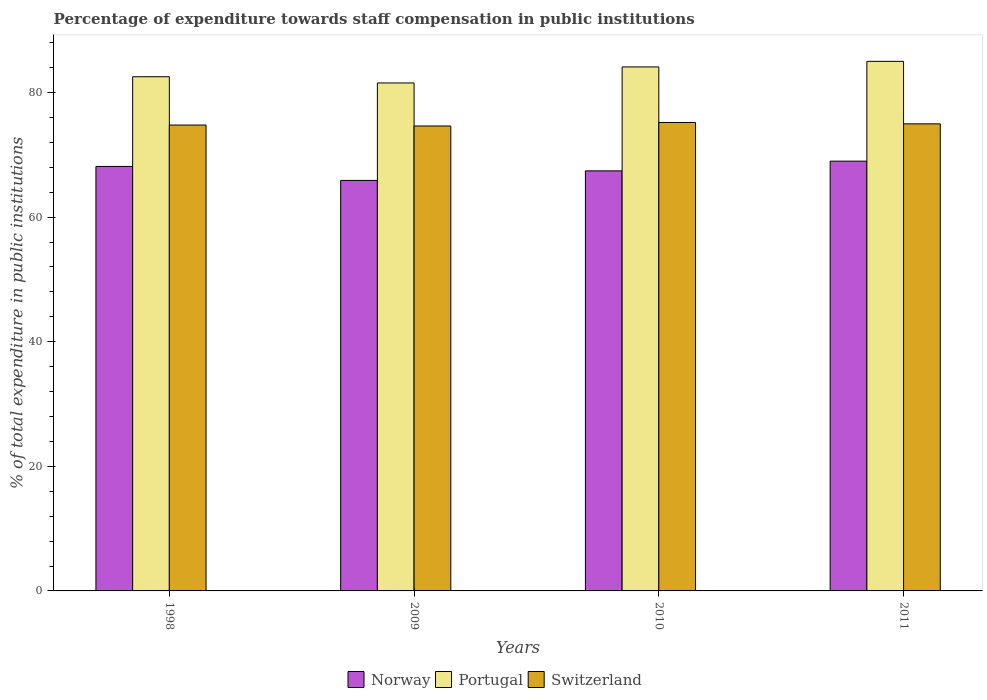How many different coloured bars are there?
Provide a succinct answer. 3. How many groups of bars are there?
Offer a terse response. 4. Are the number of bars per tick equal to the number of legend labels?
Give a very brief answer. Yes. How many bars are there on the 3rd tick from the left?
Keep it short and to the point. 3. How many bars are there on the 2nd tick from the right?
Your answer should be very brief. 3. In how many cases, is the number of bars for a given year not equal to the number of legend labels?
Ensure brevity in your answer.  0. What is the percentage of expenditure towards staff compensation in Portugal in 2009?
Offer a very short reply. 81.54. Across all years, what is the maximum percentage of expenditure towards staff compensation in Norway?
Ensure brevity in your answer.  68.99. Across all years, what is the minimum percentage of expenditure towards staff compensation in Switzerland?
Make the answer very short. 74.63. What is the total percentage of expenditure towards staff compensation in Portugal in the graph?
Keep it short and to the point. 333.19. What is the difference between the percentage of expenditure towards staff compensation in Norway in 2009 and that in 2011?
Keep it short and to the point. -3.09. What is the difference between the percentage of expenditure towards staff compensation in Norway in 2011 and the percentage of expenditure towards staff compensation in Portugal in 1998?
Ensure brevity in your answer.  -13.55. What is the average percentage of expenditure towards staff compensation in Switzerland per year?
Provide a succinct answer. 74.89. In the year 1998, what is the difference between the percentage of expenditure towards staff compensation in Switzerland and percentage of expenditure towards staff compensation in Norway?
Make the answer very short. 6.64. In how many years, is the percentage of expenditure towards staff compensation in Switzerland greater than 60 %?
Offer a very short reply. 4. What is the ratio of the percentage of expenditure towards staff compensation in Switzerland in 2009 to that in 2011?
Provide a short and direct response. 1. What is the difference between the highest and the second highest percentage of expenditure towards staff compensation in Norway?
Provide a short and direct response. 0.85. What is the difference between the highest and the lowest percentage of expenditure towards staff compensation in Portugal?
Ensure brevity in your answer.  3.47. What does the 3rd bar from the right in 2010 represents?
Give a very brief answer. Norway. How many bars are there?
Your answer should be compact. 12. What is the difference between two consecutive major ticks on the Y-axis?
Provide a short and direct response. 20. Are the values on the major ticks of Y-axis written in scientific E-notation?
Give a very brief answer. No. Does the graph contain any zero values?
Your answer should be compact. No. Where does the legend appear in the graph?
Your answer should be compact. Bottom center. How many legend labels are there?
Provide a short and direct response. 3. What is the title of the graph?
Provide a succinct answer. Percentage of expenditure towards staff compensation in public institutions. Does "Dominican Republic" appear as one of the legend labels in the graph?
Provide a short and direct response. No. What is the label or title of the X-axis?
Offer a terse response. Years. What is the label or title of the Y-axis?
Provide a succinct answer. % of total expenditure in public institutions. What is the % of total expenditure in public institutions in Norway in 1998?
Provide a short and direct response. 68.14. What is the % of total expenditure in public institutions of Portugal in 1998?
Your answer should be compact. 82.53. What is the % of total expenditure in public institutions in Switzerland in 1998?
Give a very brief answer. 74.78. What is the % of total expenditure in public institutions in Norway in 2009?
Your response must be concise. 65.89. What is the % of total expenditure in public institutions in Portugal in 2009?
Your answer should be very brief. 81.54. What is the % of total expenditure in public institutions of Switzerland in 2009?
Offer a very short reply. 74.63. What is the % of total expenditure in public institutions of Norway in 2010?
Ensure brevity in your answer.  67.42. What is the % of total expenditure in public institutions in Portugal in 2010?
Offer a very short reply. 84.11. What is the % of total expenditure in public institutions of Switzerland in 2010?
Provide a succinct answer. 75.19. What is the % of total expenditure in public institutions in Norway in 2011?
Keep it short and to the point. 68.99. What is the % of total expenditure in public institutions of Portugal in 2011?
Provide a succinct answer. 85. What is the % of total expenditure in public institutions of Switzerland in 2011?
Keep it short and to the point. 74.97. Across all years, what is the maximum % of total expenditure in public institutions in Norway?
Provide a short and direct response. 68.99. Across all years, what is the maximum % of total expenditure in public institutions in Portugal?
Offer a very short reply. 85. Across all years, what is the maximum % of total expenditure in public institutions of Switzerland?
Offer a terse response. 75.19. Across all years, what is the minimum % of total expenditure in public institutions in Norway?
Ensure brevity in your answer.  65.89. Across all years, what is the minimum % of total expenditure in public institutions in Portugal?
Give a very brief answer. 81.54. Across all years, what is the minimum % of total expenditure in public institutions of Switzerland?
Provide a succinct answer. 74.63. What is the total % of total expenditure in public institutions in Norway in the graph?
Offer a terse response. 270.44. What is the total % of total expenditure in public institutions of Portugal in the graph?
Give a very brief answer. 333.19. What is the total % of total expenditure in public institutions of Switzerland in the graph?
Provide a short and direct response. 299.57. What is the difference between the % of total expenditure in public institutions of Norway in 1998 and that in 2009?
Keep it short and to the point. 2.24. What is the difference between the % of total expenditure in public institutions in Switzerland in 1998 and that in 2009?
Make the answer very short. 0.15. What is the difference between the % of total expenditure in public institutions of Norway in 1998 and that in 2010?
Ensure brevity in your answer.  0.71. What is the difference between the % of total expenditure in public institutions in Portugal in 1998 and that in 2010?
Provide a succinct answer. -1.58. What is the difference between the % of total expenditure in public institutions of Switzerland in 1998 and that in 2010?
Provide a short and direct response. -0.41. What is the difference between the % of total expenditure in public institutions of Norway in 1998 and that in 2011?
Your answer should be compact. -0.85. What is the difference between the % of total expenditure in public institutions in Portugal in 1998 and that in 2011?
Ensure brevity in your answer.  -2.47. What is the difference between the % of total expenditure in public institutions in Switzerland in 1998 and that in 2011?
Your response must be concise. -0.19. What is the difference between the % of total expenditure in public institutions in Norway in 2009 and that in 2010?
Ensure brevity in your answer.  -1.53. What is the difference between the % of total expenditure in public institutions in Portugal in 2009 and that in 2010?
Ensure brevity in your answer.  -2.57. What is the difference between the % of total expenditure in public institutions in Switzerland in 2009 and that in 2010?
Offer a very short reply. -0.56. What is the difference between the % of total expenditure in public institutions in Norway in 2009 and that in 2011?
Give a very brief answer. -3.09. What is the difference between the % of total expenditure in public institutions in Portugal in 2009 and that in 2011?
Your answer should be compact. -3.47. What is the difference between the % of total expenditure in public institutions in Switzerland in 2009 and that in 2011?
Ensure brevity in your answer.  -0.34. What is the difference between the % of total expenditure in public institutions in Norway in 2010 and that in 2011?
Your answer should be compact. -1.56. What is the difference between the % of total expenditure in public institutions of Portugal in 2010 and that in 2011?
Offer a terse response. -0.89. What is the difference between the % of total expenditure in public institutions in Switzerland in 2010 and that in 2011?
Keep it short and to the point. 0.22. What is the difference between the % of total expenditure in public institutions of Norway in 1998 and the % of total expenditure in public institutions of Portugal in 2009?
Ensure brevity in your answer.  -13.4. What is the difference between the % of total expenditure in public institutions of Norway in 1998 and the % of total expenditure in public institutions of Switzerland in 2009?
Your answer should be very brief. -6.49. What is the difference between the % of total expenditure in public institutions of Portugal in 1998 and the % of total expenditure in public institutions of Switzerland in 2009?
Keep it short and to the point. 7.91. What is the difference between the % of total expenditure in public institutions in Norway in 1998 and the % of total expenditure in public institutions in Portugal in 2010?
Give a very brief answer. -15.97. What is the difference between the % of total expenditure in public institutions of Norway in 1998 and the % of total expenditure in public institutions of Switzerland in 2010?
Your answer should be very brief. -7.06. What is the difference between the % of total expenditure in public institutions in Portugal in 1998 and the % of total expenditure in public institutions in Switzerland in 2010?
Make the answer very short. 7.34. What is the difference between the % of total expenditure in public institutions in Norway in 1998 and the % of total expenditure in public institutions in Portugal in 2011?
Offer a very short reply. -16.87. What is the difference between the % of total expenditure in public institutions in Norway in 1998 and the % of total expenditure in public institutions in Switzerland in 2011?
Your answer should be very brief. -6.84. What is the difference between the % of total expenditure in public institutions in Portugal in 1998 and the % of total expenditure in public institutions in Switzerland in 2011?
Offer a terse response. 7.56. What is the difference between the % of total expenditure in public institutions in Norway in 2009 and the % of total expenditure in public institutions in Portugal in 2010?
Your answer should be compact. -18.22. What is the difference between the % of total expenditure in public institutions of Norway in 2009 and the % of total expenditure in public institutions of Switzerland in 2010?
Offer a terse response. -9.3. What is the difference between the % of total expenditure in public institutions of Portugal in 2009 and the % of total expenditure in public institutions of Switzerland in 2010?
Offer a terse response. 6.35. What is the difference between the % of total expenditure in public institutions in Norway in 2009 and the % of total expenditure in public institutions in Portugal in 2011?
Provide a succinct answer. -19.11. What is the difference between the % of total expenditure in public institutions in Norway in 2009 and the % of total expenditure in public institutions in Switzerland in 2011?
Offer a very short reply. -9.08. What is the difference between the % of total expenditure in public institutions in Portugal in 2009 and the % of total expenditure in public institutions in Switzerland in 2011?
Provide a succinct answer. 6.57. What is the difference between the % of total expenditure in public institutions in Norway in 2010 and the % of total expenditure in public institutions in Portugal in 2011?
Offer a terse response. -17.58. What is the difference between the % of total expenditure in public institutions of Norway in 2010 and the % of total expenditure in public institutions of Switzerland in 2011?
Provide a succinct answer. -7.55. What is the difference between the % of total expenditure in public institutions of Portugal in 2010 and the % of total expenditure in public institutions of Switzerland in 2011?
Provide a short and direct response. 9.14. What is the average % of total expenditure in public institutions in Norway per year?
Provide a short and direct response. 67.61. What is the average % of total expenditure in public institutions in Portugal per year?
Give a very brief answer. 83.3. What is the average % of total expenditure in public institutions in Switzerland per year?
Your answer should be compact. 74.89. In the year 1998, what is the difference between the % of total expenditure in public institutions of Norway and % of total expenditure in public institutions of Portugal?
Keep it short and to the point. -14.4. In the year 1998, what is the difference between the % of total expenditure in public institutions in Norway and % of total expenditure in public institutions in Switzerland?
Make the answer very short. -6.64. In the year 1998, what is the difference between the % of total expenditure in public institutions in Portugal and % of total expenditure in public institutions in Switzerland?
Keep it short and to the point. 7.75. In the year 2009, what is the difference between the % of total expenditure in public institutions of Norway and % of total expenditure in public institutions of Portugal?
Provide a succinct answer. -15.64. In the year 2009, what is the difference between the % of total expenditure in public institutions in Norway and % of total expenditure in public institutions in Switzerland?
Offer a very short reply. -8.74. In the year 2009, what is the difference between the % of total expenditure in public institutions of Portugal and % of total expenditure in public institutions of Switzerland?
Ensure brevity in your answer.  6.91. In the year 2010, what is the difference between the % of total expenditure in public institutions of Norway and % of total expenditure in public institutions of Portugal?
Your answer should be compact. -16.69. In the year 2010, what is the difference between the % of total expenditure in public institutions in Norway and % of total expenditure in public institutions in Switzerland?
Offer a very short reply. -7.77. In the year 2010, what is the difference between the % of total expenditure in public institutions in Portugal and % of total expenditure in public institutions in Switzerland?
Your answer should be compact. 8.92. In the year 2011, what is the difference between the % of total expenditure in public institutions in Norway and % of total expenditure in public institutions in Portugal?
Offer a terse response. -16.02. In the year 2011, what is the difference between the % of total expenditure in public institutions of Norway and % of total expenditure in public institutions of Switzerland?
Offer a very short reply. -5.99. In the year 2011, what is the difference between the % of total expenditure in public institutions in Portugal and % of total expenditure in public institutions in Switzerland?
Give a very brief answer. 10.03. What is the ratio of the % of total expenditure in public institutions in Norway in 1998 to that in 2009?
Offer a terse response. 1.03. What is the ratio of the % of total expenditure in public institutions of Portugal in 1998 to that in 2009?
Offer a very short reply. 1.01. What is the ratio of the % of total expenditure in public institutions in Norway in 1998 to that in 2010?
Offer a very short reply. 1.01. What is the ratio of the % of total expenditure in public institutions of Portugal in 1998 to that in 2010?
Your answer should be compact. 0.98. What is the ratio of the % of total expenditure in public institutions in Switzerland in 1998 to that in 2010?
Your answer should be very brief. 0.99. What is the ratio of the % of total expenditure in public institutions in Portugal in 1998 to that in 2011?
Provide a succinct answer. 0.97. What is the ratio of the % of total expenditure in public institutions of Norway in 2009 to that in 2010?
Provide a succinct answer. 0.98. What is the ratio of the % of total expenditure in public institutions in Portugal in 2009 to that in 2010?
Provide a short and direct response. 0.97. What is the ratio of the % of total expenditure in public institutions of Switzerland in 2009 to that in 2010?
Ensure brevity in your answer.  0.99. What is the ratio of the % of total expenditure in public institutions in Norway in 2009 to that in 2011?
Provide a succinct answer. 0.96. What is the ratio of the % of total expenditure in public institutions of Portugal in 2009 to that in 2011?
Keep it short and to the point. 0.96. What is the ratio of the % of total expenditure in public institutions in Norway in 2010 to that in 2011?
Make the answer very short. 0.98. What is the difference between the highest and the second highest % of total expenditure in public institutions of Norway?
Offer a terse response. 0.85. What is the difference between the highest and the second highest % of total expenditure in public institutions of Portugal?
Offer a very short reply. 0.89. What is the difference between the highest and the second highest % of total expenditure in public institutions of Switzerland?
Provide a succinct answer. 0.22. What is the difference between the highest and the lowest % of total expenditure in public institutions of Norway?
Ensure brevity in your answer.  3.09. What is the difference between the highest and the lowest % of total expenditure in public institutions of Portugal?
Offer a terse response. 3.47. What is the difference between the highest and the lowest % of total expenditure in public institutions in Switzerland?
Make the answer very short. 0.56. 